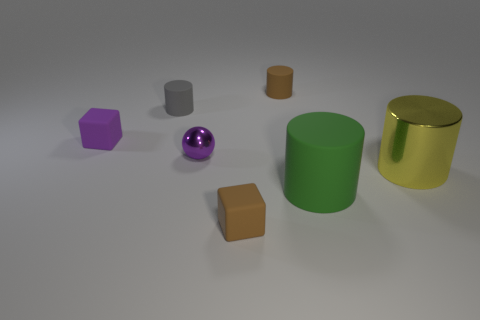Is the material of the tiny brown cube the same as the cylinder that is to the left of the small brown matte cylinder?
Offer a very short reply. Yes. What number of red things are either cubes or big metal things?
Give a very brief answer. 0. What size is the purple cube that is the same material as the small brown cylinder?
Provide a short and direct response. Small. What number of brown objects are the same shape as the green matte object?
Provide a short and direct response. 1. Are there more small brown rubber objects behind the gray rubber cylinder than objects to the left of the big green cylinder?
Your response must be concise. No. There is a tiny sphere; is it the same color as the cylinder to the left of the small purple metal sphere?
Offer a terse response. No. There is a green thing that is the same size as the yellow cylinder; what is it made of?
Provide a succinct answer. Rubber. How many things are big blue metal cubes or things on the right side of the small metal ball?
Provide a succinct answer. 4. Is the size of the purple rubber block the same as the gray cylinder behind the purple block?
Offer a terse response. Yes. How many cylinders are either tiny brown rubber things or gray rubber things?
Give a very brief answer. 2. 